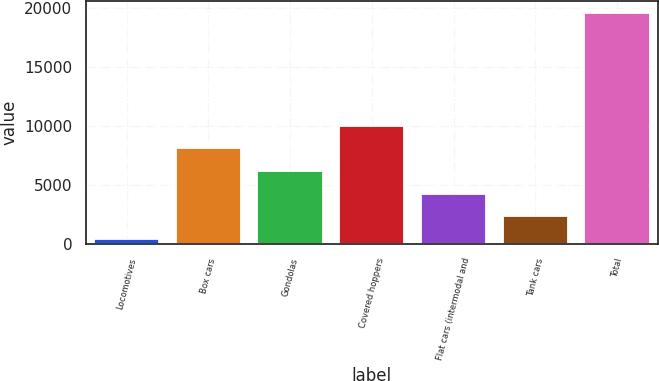<chart> <loc_0><loc_0><loc_500><loc_500><bar_chart><fcel>Locomotives<fcel>Box cars<fcel>Gondolas<fcel>Covered hoppers<fcel>Flat cars (intermodal and<fcel>Tank cars<fcel>Total<nl><fcel>417<fcel>8097.4<fcel>6177.3<fcel>10017.5<fcel>4257.2<fcel>2337.1<fcel>19618<nl></chart> 